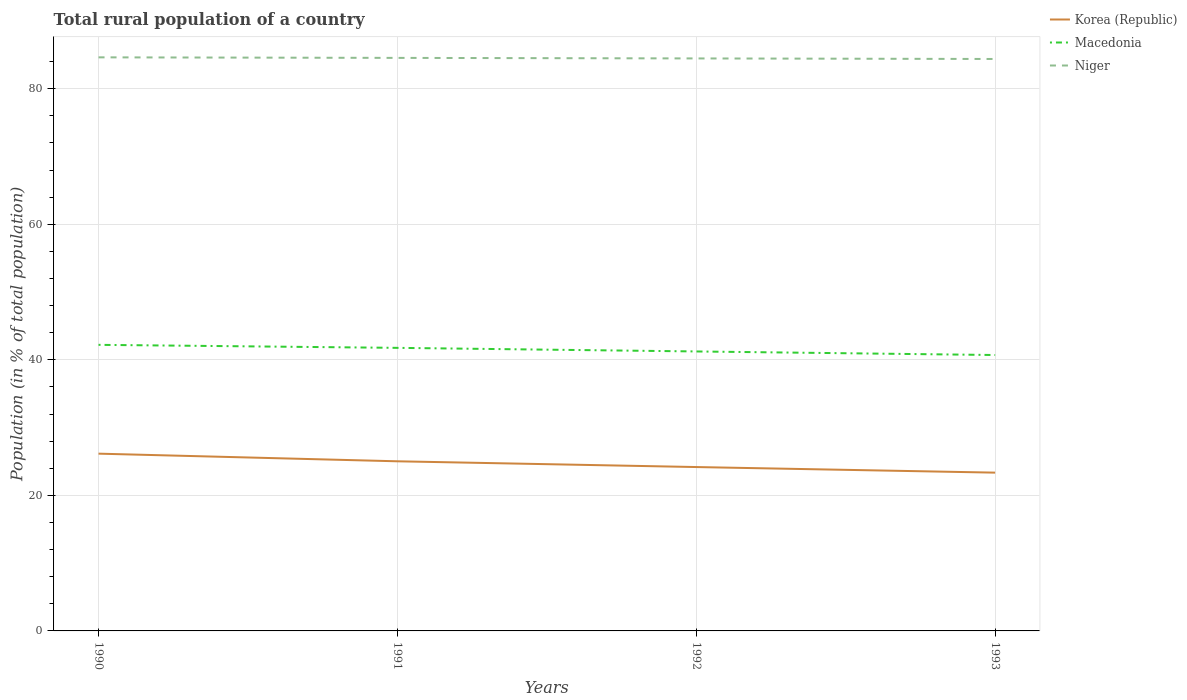Is the number of lines equal to the number of legend labels?
Make the answer very short. Yes. Across all years, what is the maximum rural population in Macedonia?
Make the answer very short. 40.71. In which year was the rural population in Niger maximum?
Your response must be concise. 1993. What is the total rural population in Korea (Republic) in the graph?
Your answer should be compact. 0.82. What is the difference between the highest and the second highest rural population in Korea (Republic)?
Make the answer very short. 2.8. Is the rural population in Korea (Republic) strictly greater than the rural population in Macedonia over the years?
Your answer should be compact. Yes. How many lines are there?
Your response must be concise. 3. What is the difference between two consecutive major ticks on the Y-axis?
Make the answer very short. 20. Where does the legend appear in the graph?
Your answer should be very brief. Top right. How are the legend labels stacked?
Your answer should be very brief. Vertical. What is the title of the graph?
Your answer should be compact. Total rural population of a country. What is the label or title of the Y-axis?
Give a very brief answer. Population (in % of total population). What is the Population (in % of total population) of Korea (Republic) in 1990?
Ensure brevity in your answer.  26.16. What is the Population (in % of total population) of Macedonia in 1990?
Make the answer very short. 42.21. What is the Population (in % of total population) of Niger in 1990?
Keep it short and to the point. 84.63. What is the Population (in % of total population) of Korea (Republic) in 1991?
Make the answer very short. 25.03. What is the Population (in % of total population) of Macedonia in 1991?
Offer a terse response. 41.77. What is the Population (in % of total population) of Niger in 1991?
Your answer should be very brief. 84.55. What is the Population (in % of total population) in Korea (Republic) in 1992?
Your answer should be very brief. 24.18. What is the Population (in % of total population) in Macedonia in 1992?
Give a very brief answer. 41.24. What is the Population (in % of total population) in Niger in 1992?
Offer a very short reply. 84.47. What is the Population (in % of total population) of Korea (Republic) in 1993?
Your response must be concise. 23.36. What is the Population (in % of total population) in Macedonia in 1993?
Keep it short and to the point. 40.71. What is the Population (in % of total population) in Niger in 1993?
Ensure brevity in your answer.  84.39. Across all years, what is the maximum Population (in % of total population) in Korea (Republic)?
Give a very brief answer. 26.16. Across all years, what is the maximum Population (in % of total population) in Macedonia?
Your answer should be compact. 42.21. Across all years, what is the maximum Population (in % of total population) of Niger?
Your answer should be very brief. 84.63. Across all years, what is the minimum Population (in % of total population) of Korea (Republic)?
Provide a short and direct response. 23.36. Across all years, what is the minimum Population (in % of total population) of Macedonia?
Your answer should be compact. 40.71. Across all years, what is the minimum Population (in % of total population) in Niger?
Give a very brief answer. 84.39. What is the total Population (in % of total population) in Korea (Republic) in the graph?
Your answer should be compact. 98.72. What is the total Population (in % of total population) of Macedonia in the graph?
Offer a terse response. 165.92. What is the total Population (in % of total population) in Niger in the graph?
Your response must be concise. 338.04. What is the difference between the Population (in % of total population) in Korea (Republic) in 1990 and that in 1991?
Give a very brief answer. 1.13. What is the difference between the Population (in % of total population) in Macedonia in 1990 and that in 1991?
Make the answer very short. 0.45. What is the difference between the Population (in % of total population) of Niger in 1990 and that in 1991?
Offer a very short reply. 0.08. What is the difference between the Population (in % of total population) of Korea (Republic) in 1990 and that in 1992?
Offer a very short reply. 1.98. What is the difference between the Population (in % of total population) in Macedonia in 1990 and that in 1992?
Provide a succinct answer. 0.97. What is the difference between the Population (in % of total population) in Niger in 1990 and that in 1992?
Your answer should be compact. 0.16. What is the difference between the Population (in % of total population) of Korea (Republic) in 1990 and that in 1993?
Give a very brief answer. 2.8. What is the difference between the Population (in % of total population) in Macedonia in 1990 and that in 1993?
Offer a terse response. 1.5. What is the difference between the Population (in % of total population) in Niger in 1990 and that in 1993?
Ensure brevity in your answer.  0.24. What is the difference between the Population (in % of total population) in Korea (Republic) in 1991 and that in 1992?
Offer a very short reply. 0.85. What is the difference between the Population (in % of total population) in Macedonia in 1991 and that in 1992?
Your answer should be compact. 0.53. What is the difference between the Population (in % of total population) in Niger in 1991 and that in 1992?
Your answer should be compact. 0.08. What is the difference between the Population (in % of total population) of Korea (Republic) in 1991 and that in 1993?
Offer a terse response. 1.67. What is the difference between the Population (in % of total population) in Macedonia in 1991 and that in 1993?
Keep it short and to the point. 1.06. What is the difference between the Population (in % of total population) of Niger in 1991 and that in 1993?
Provide a short and direct response. 0.16. What is the difference between the Population (in % of total population) of Korea (Republic) in 1992 and that in 1993?
Your response must be concise. 0.82. What is the difference between the Population (in % of total population) of Macedonia in 1992 and that in 1993?
Ensure brevity in your answer.  0.53. What is the difference between the Population (in % of total population) in Niger in 1992 and that in 1993?
Your answer should be very brief. 0.08. What is the difference between the Population (in % of total population) of Korea (Republic) in 1990 and the Population (in % of total population) of Macedonia in 1991?
Your answer should be compact. -15.61. What is the difference between the Population (in % of total population) in Korea (Republic) in 1990 and the Population (in % of total population) in Niger in 1991?
Offer a very short reply. -58.4. What is the difference between the Population (in % of total population) in Macedonia in 1990 and the Population (in % of total population) in Niger in 1991?
Keep it short and to the point. -42.34. What is the difference between the Population (in % of total population) of Korea (Republic) in 1990 and the Population (in % of total population) of Macedonia in 1992?
Your response must be concise. -15.08. What is the difference between the Population (in % of total population) of Korea (Republic) in 1990 and the Population (in % of total population) of Niger in 1992?
Ensure brevity in your answer.  -58.31. What is the difference between the Population (in % of total population) of Macedonia in 1990 and the Population (in % of total population) of Niger in 1992?
Make the answer very short. -42.26. What is the difference between the Population (in % of total population) in Korea (Republic) in 1990 and the Population (in % of total population) in Macedonia in 1993?
Offer a terse response. -14.55. What is the difference between the Population (in % of total population) in Korea (Republic) in 1990 and the Population (in % of total population) in Niger in 1993?
Your response must be concise. -58.23. What is the difference between the Population (in % of total population) in Macedonia in 1990 and the Population (in % of total population) in Niger in 1993?
Make the answer very short. -42.18. What is the difference between the Population (in % of total population) in Korea (Republic) in 1991 and the Population (in % of total population) in Macedonia in 1992?
Make the answer very short. -16.21. What is the difference between the Population (in % of total population) of Korea (Republic) in 1991 and the Population (in % of total population) of Niger in 1992?
Keep it short and to the point. -59.44. What is the difference between the Population (in % of total population) of Macedonia in 1991 and the Population (in % of total population) of Niger in 1992?
Your answer should be compact. -42.7. What is the difference between the Population (in % of total population) in Korea (Republic) in 1991 and the Population (in % of total population) in Macedonia in 1993?
Provide a short and direct response. -15.68. What is the difference between the Population (in % of total population) in Korea (Republic) in 1991 and the Population (in % of total population) in Niger in 1993?
Provide a short and direct response. -59.36. What is the difference between the Population (in % of total population) of Macedonia in 1991 and the Population (in % of total population) of Niger in 1993?
Provide a short and direct response. -42.62. What is the difference between the Population (in % of total population) in Korea (Republic) in 1992 and the Population (in % of total population) in Macedonia in 1993?
Offer a terse response. -16.53. What is the difference between the Population (in % of total population) in Korea (Republic) in 1992 and the Population (in % of total population) in Niger in 1993?
Make the answer very short. -60.21. What is the difference between the Population (in % of total population) in Macedonia in 1992 and the Population (in % of total population) in Niger in 1993?
Your answer should be very brief. -43.15. What is the average Population (in % of total population) in Korea (Republic) per year?
Make the answer very short. 24.68. What is the average Population (in % of total population) in Macedonia per year?
Offer a very short reply. 41.48. What is the average Population (in % of total population) of Niger per year?
Provide a succinct answer. 84.51. In the year 1990, what is the difference between the Population (in % of total population) in Korea (Republic) and Population (in % of total population) in Macedonia?
Your answer should be compact. -16.05. In the year 1990, what is the difference between the Population (in % of total population) in Korea (Republic) and Population (in % of total population) in Niger?
Give a very brief answer. -58.48. In the year 1990, what is the difference between the Population (in % of total population) in Macedonia and Population (in % of total population) in Niger?
Ensure brevity in your answer.  -42.42. In the year 1991, what is the difference between the Population (in % of total population) of Korea (Republic) and Population (in % of total population) of Macedonia?
Offer a very short reply. -16.74. In the year 1991, what is the difference between the Population (in % of total population) of Korea (Republic) and Population (in % of total population) of Niger?
Provide a short and direct response. -59.52. In the year 1991, what is the difference between the Population (in % of total population) of Macedonia and Population (in % of total population) of Niger?
Provide a succinct answer. -42.78. In the year 1992, what is the difference between the Population (in % of total population) in Korea (Republic) and Population (in % of total population) in Macedonia?
Provide a succinct answer. -17.06. In the year 1992, what is the difference between the Population (in % of total population) of Korea (Republic) and Population (in % of total population) of Niger?
Make the answer very short. -60.29. In the year 1992, what is the difference between the Population (in % of total population) of Macedonia and Population (in % of total population) of Niger?
Keep it short and to the point. -43.23. In the year 1993, what is the difference between the Population (in % of total population) in Korea (Republic) and Population (in % of total population) in Macedonia?
Provide a succinct answer. -17.35. In the year 1993, what is the difference between the Population (in % of total population) of Korea (Republic) and Population (in % of total population) of Niger?
Ensure brevity in your answer.  -61.03. In the year 1993, what is the difference between the Population (in % of total population) of Macedonia and Population (in % of total population) of Niger?
Offer a very short reply. -43.68. What is the ratio of the Population (in % of total population) of Korea (Republic) in 1990 to that in 1991?
Provide a succinct answer. 1.05. What is the ratio of the Population (in % of total population) in Macedonia in 1990 to that in 1991?
Offer a terse response. 1.01. What is the ratio of the Population (in % of total population) of Niger in 1990 to that in 1991?
Offer a terse response. 1. What is the ratio of the Population (in % of total population) of Korea (Republic) in 1990 to that in 1992?
Offer a very short reply. 1.08. What is the ratio of the Population (in % of total population) in Macedonia in 1990 to that in 1992?
Ensure brevity in your answer.  1.02. What is the ratio of the Population (in % of total population) in Korea (Republic) in 1990 to that in 1993?
Provide a short and direct response. 1.12. What is the ratio of the Population (in % of total population) of Macedonia in 1990 to that in 1993?
Provide a succinct answer. 1.04. What is the ratio of the Population (in % of total population) of Niger in 1990 to that in 1993?
Provide a short and direct response. 1. What is the ratio of the Population (in % of total population) in Korea (Republic) in 1991 to that in 1992?
Give a very brief answer. 1.04. What is the ratio of the Population (in % of total population) of Macedonia in 1991 to that in 1992?
Your answer should be compact. 1.01. What is the ratio of the Population (in % of total population) in Korea (Republic) in 1991 to that in 1993?
Keep it short and to the point. 1.07. What is the ratio of the Population (in % of total population) in Korea (Republic) in 1992 to that in 1993?
Your response must be concise. 1.04. What is the ratio of the Population (in % of total population) of Macedonia in 1992 to that in 1993?
Make the answer very short. 1.01. What is the difference between the highest and the second highest Population (in % of total population) in Korea (Republic)?
Your response must be concise. 1.13. What is the difference between the highest and the second highest Population (in % of total population) in Macedonia?
Give a very brief answer. 0.45. What is the difference between the highest and the second highest Population (in % of total population) of Niger?
Ensure brevity in your answer.  0.08. What is the difference between the highest and the lowest Population (in % of total population) in Korea (Republic)?
Make the answer very short. 2.8. What is the difference between the highest and the lowest Population (in % of total population) in Macedonia?
Your response must be concise. 1.5. What is the difference between the highest and the lowest Population (in % of total population) in Niger?
Give a very brief answer. 0.24. 